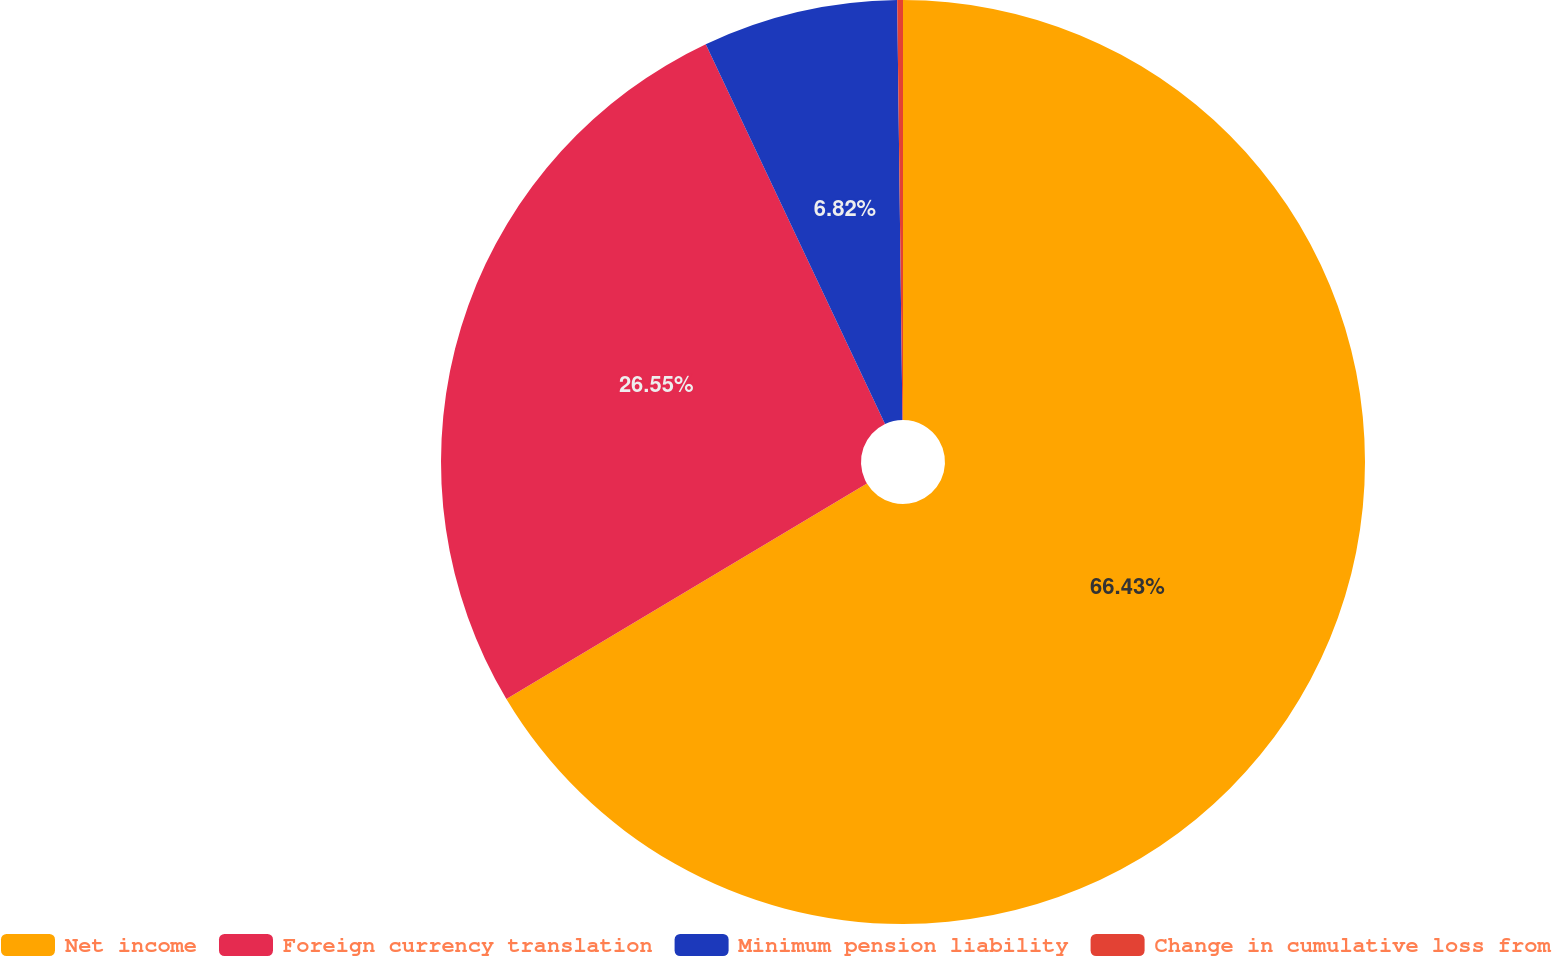<chart> <loc_0><loc_0><loc_500><loc_500><pie_chart><fcel>Net income<fcel>Foreign currency translation<fcel>Minimum pension liability<fcel>Change in cumulative loss from<nl><fcel>66.43%<fcel>26.55%<fcel>6.82%<fcel>0.2%<nl></chart> 